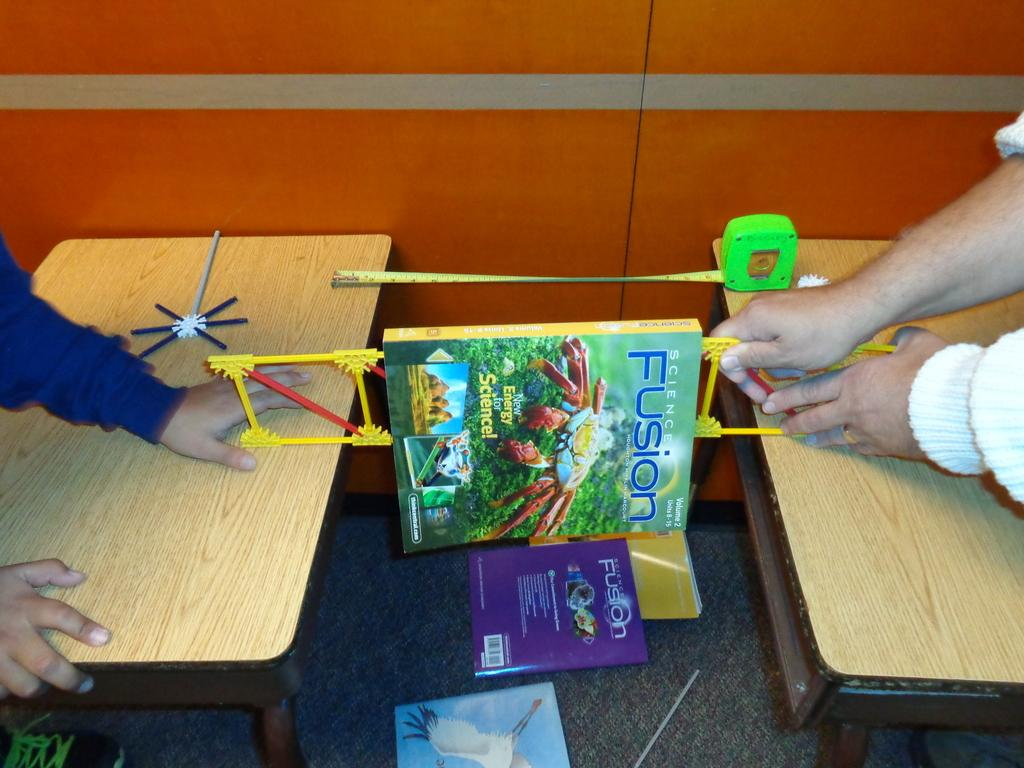<image>
Render a clear and concise summary of the photo. A Fusion book is placed over a toy bridge. 